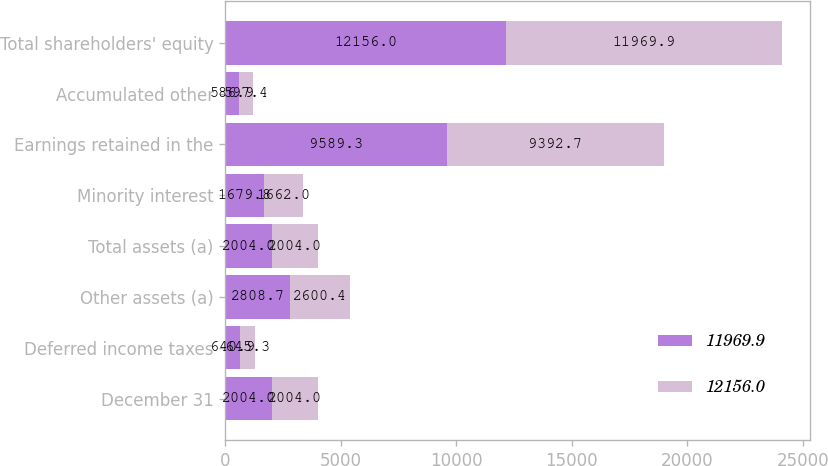Convert chart to OTSL. <chart><loc_0><loc_0><loc_500><loc_500><stacked_bar_chart><ecel><fcel>December 31<fcel>Deferred income taxes<fcel>Other assets (a)<fcel>Total assets (a)<fcel>Minority interest<fcel>Earnings retained in the<fcel>Accumulated other<fcel>Total shareholders' equity<nl><fcel>11969.9<fcel>2004<fcel>640.9<fcel>2808.7<fcel>2004<fcel>1679.8<fcel>9589.3<fcel>586.9<fcel>12156<nl><fcel>12156<fcel>2004<fcel>645.3<fcel>2600.4<fcel>2004<fcel>1662<fcel>9392.7<fcel>597.4<fcel>11969.9<nl></chart> 